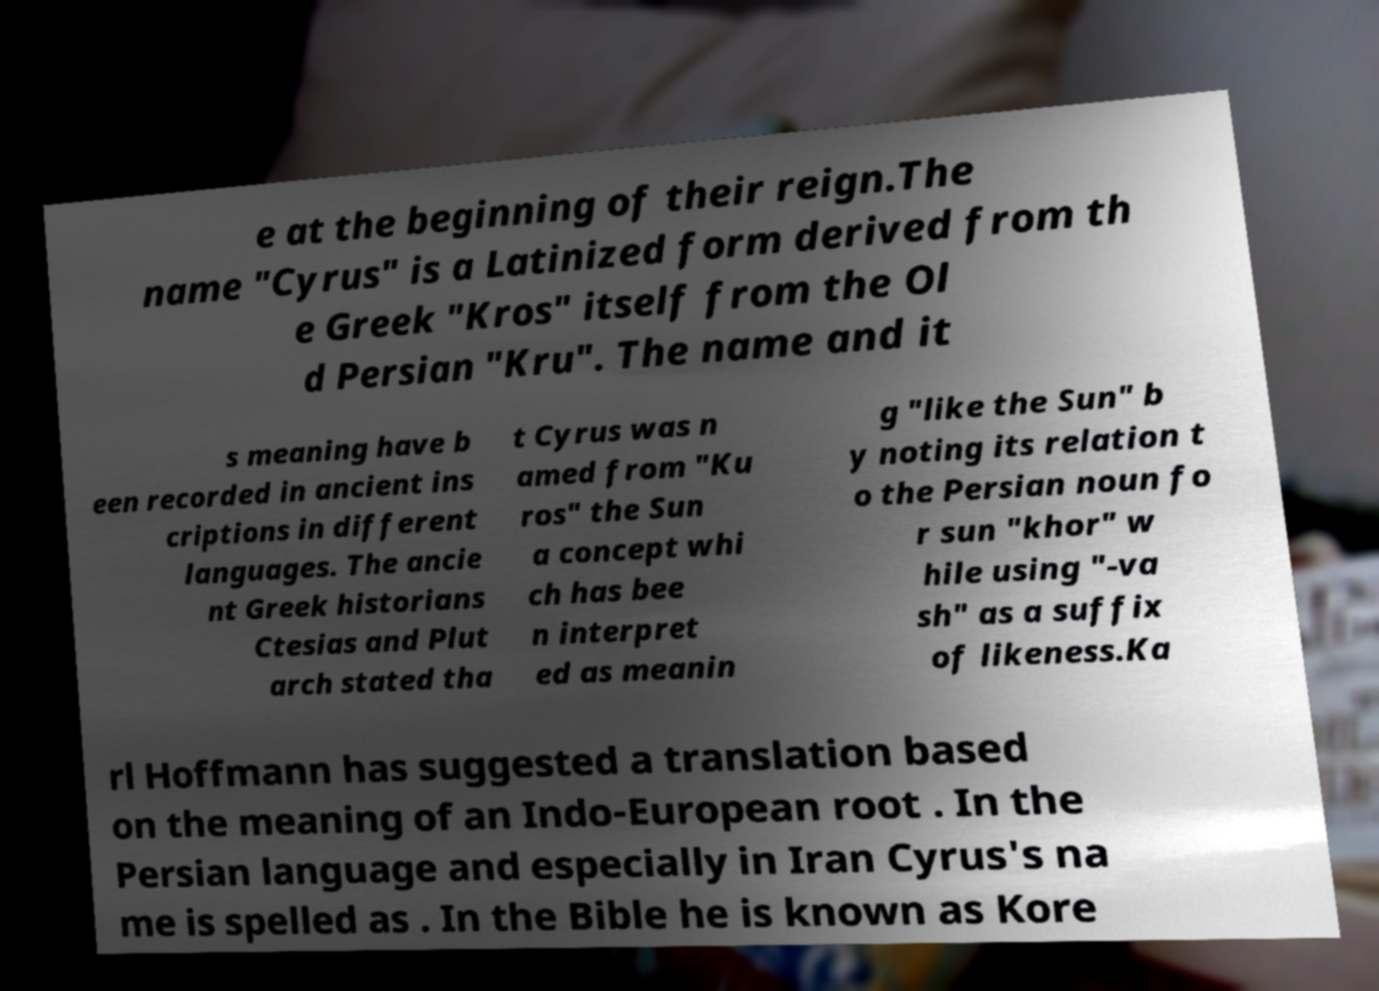Can you read and provide the text displayed in the image?This photo seems to have some interesting text. Can you extract and type it out for me? e at the beginning of their reign.The name "Cyrus" is a Latinized form derived from th e Greek "Kros" itself from the Ol d Persian "Kru". The name and it s meaning have b een recorded in ancient ins criptions in different languages. The ancie nt Greek historians Ctesias and Plut arch stated tha t Cyrus was n amed from "Ku ros" the Sun a concept whi ch has bee n interpret ed as meanin g "like the Sun" b y noting its relation t o the Persian noun fo r sun "khor" w hile using "-va sh" as a suffix of likeness.Ka rl Hoffmann has suggested a translation based on the meaning of an Indo-European root . In the Persian language and especially in Iran Cyrus's na me is spelled as . In the Bible he is known as Kore 